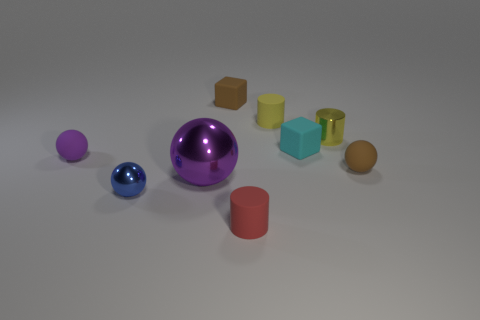Subtract all tiny purple spheres. How many spheres are left? 3 Subtract 1 cylinders. How many cylinders are left? 2 Subtract all cyan spheres. Subtract all blue cylinders. How many spheres are left? 4 Add 1 tiny rubber things. How many objects exist? 10 Subtract all cylinders. How many objects are left? 6 Subtract 0 cyan cylinders. How many objects are left? 9 Subtract all purple shiny spheres. Subtract all tiny yellow cylinders. How many objects are left? 6 Add 5 brown spheres. How many brown spheres are left? 6 Add 1 large shiny objects. How many large shiny objects exist? 2 